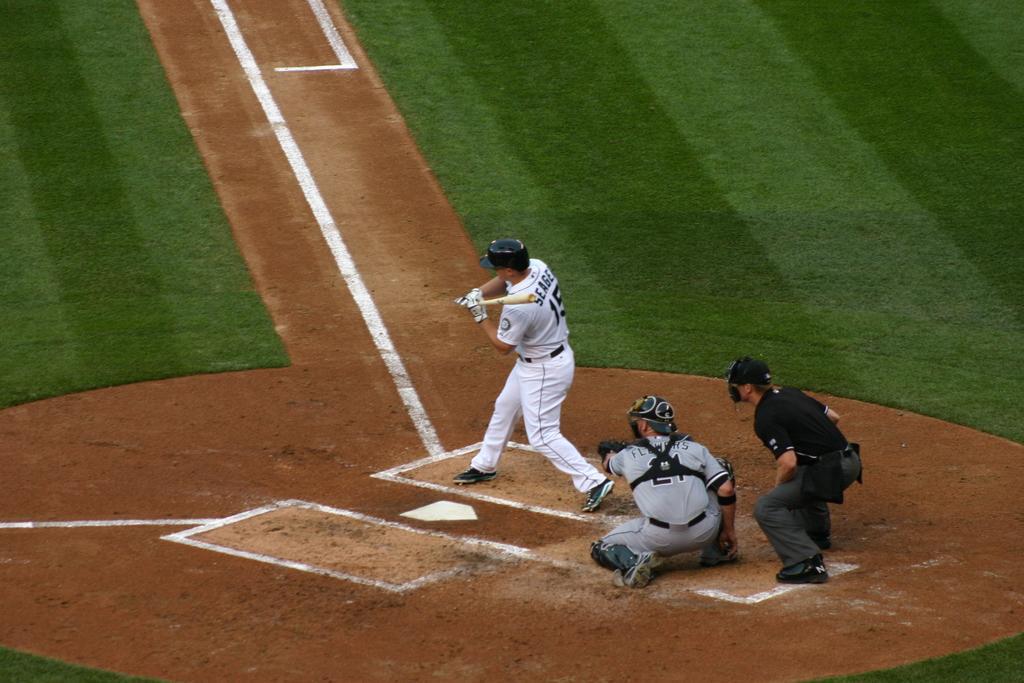Please provide a concise description of this image. In this image I can see a person wearing white jersey and white helmet is standing and holding a bat in his hands. I can see two other persons behind him. In the background I can see the baseball court. 